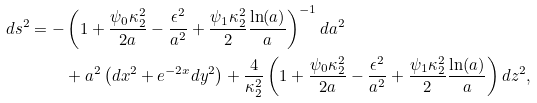<formula> <loc_0><loc_0><loc_500><loc_500>d s ^ { 2 } = - & \left ( 1 + \frac { \psi _ { 0 } \kappa _ { 2 } ^ { 2 } } { 2 a } - \frac { \epsilon ^ { 2 } } { a ^ { 2 } } + \frac { \psi _ { 1 } \kappa _ { 2 } ^ { 2 } } { 2 } \frac { \ln ( a ) } { a } \right ) ^ { - 1 } d a ^ { 2 } \\ & + a ^ { 2 } \left ( d x ^ { 2 } + e ^ { - 2 x } d y ^ { 2 } \right ) + \frac { 4 } { \kappa _ { 2 } ^ { 2 } } \left ( 1 + \frac { \psi _ { 0 } \kappa _ { 2 } ^ { 2 } } { 2 a } - \frac { \epsilon ^ { 2 } } { a ^ { 2 } } + \frac { \psi _ { 1 } \kappa _ { 2 } ^ { 2 } } { 2 } \frac { \ln ( a ) } { a } \right ) d z ^ { 2 } ,</formula> 